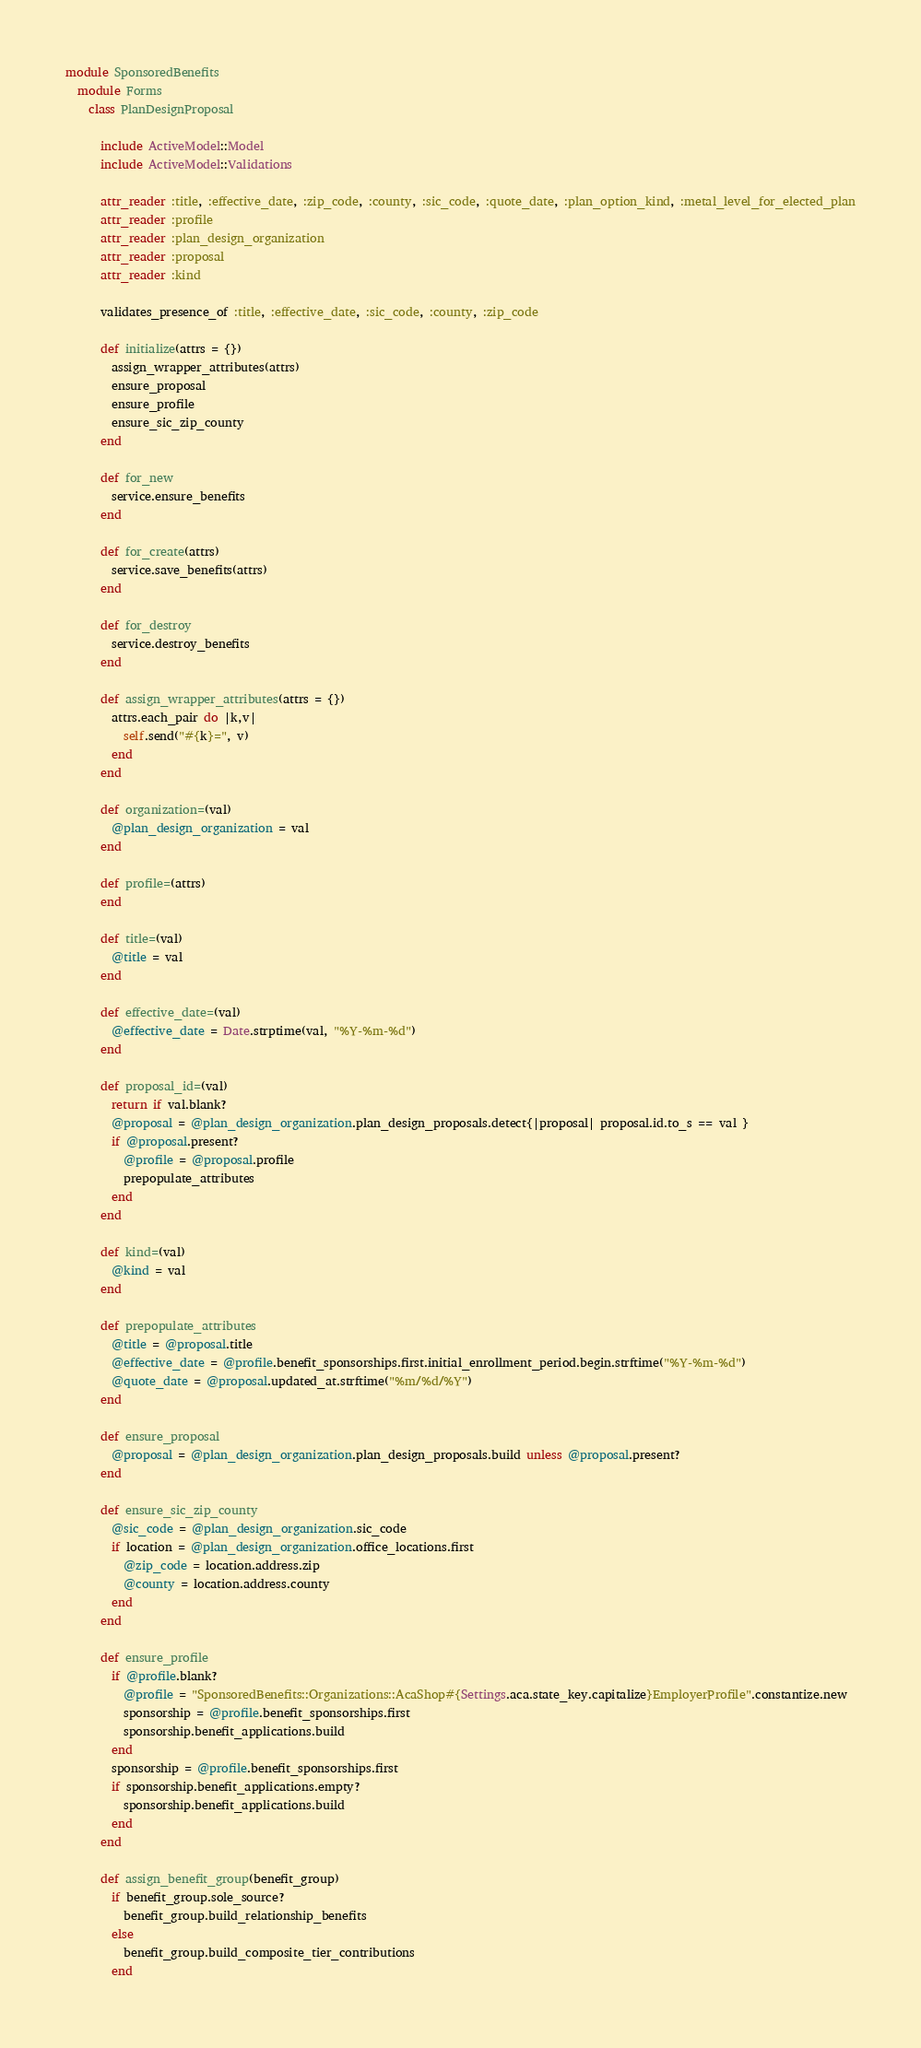Convert code to text. <code><loc_0><loc_0><loc_500><loc_500><_Ruby_>module SponsoredBenefits
  module Forms
    class PlanDesignProposal

      include ActiveModel::Model
      include ActiveModel::Validations

      attr_reader :title, :effective_date, :zip_code, :county, :sic_code, :quote_date, :plan_option_kind, :metal_level_for_elected_plan
      attr_reader :profile
      attr_reader :plan_design_organization
      attr_reader :proposal
      attr_reader :kind

      validates_presence_of :title, :effective_date, :sic_code, :county, :zip_code

      def initialize(attrs = {})
        assign_wrapper_attributes(attrs)
        ensure_proposal
        ensure_profile
        ensure_sic_zip_county
      end

      def for_new
        service.ensure_benefits
      end

      def for_create(attrs)
        service.save_benefits(attrs)
      end

      def for_destroy
        service.destroy_benefits
      end

      def assign_wrapper_attributes(attrs = {})
        attrs.each_pair do |k,v|
          self.send("#{k}=", v)
        end
      end

      def organization=(val)
        @plan_design_organization = val
      end

      def profile=(attrs)
      end

      def title=(val)
        @title = val
      end

      def effective_date=(val)
        @effective_date = Date.strptime(val, "%Y-%m-%d")
      end

      def proposal_id=(val)
        return if val.blank?
        @proposal = @plan_design_organization.plan_design_proposals.detect{|proposal| proposal.id.to_s == val }
        if @proposal.present?
          @profile = @proposal.profile
          prepopulate_attributes
        end
      end

      def kind=(val)
        @kind = val
      end

      def prepopulate_attributes
        @title = @proposal.title
        @effective_date = @profile.benefit_sponsorships.first.initial_enrollment_period.begin.strftime("%Y-%m-%d")
        @quote_date = @proposal.updated_at.strftime("%m/%d/%Y")
      end

      def ensure_proposal
        @proposal = @plan_design_organization.plan_design_proposals.build unless @proposal.present?
      end

      def ensure_sic_zip_county
        @sic_code = @plan_design_organization.sic_code
        if location = @plan_design_organization.office_locations.first
          @zip_code = location.address.zip
          @county = location.address.county
        end
      end

      def ensure_profile
        if @profile.blank?
          @profile = "SponsoredBenefits::Organizations::AcaShop#{Settings.aca.state_key.capitalize}EmployerProfile".constantize.new
          sponsorship = @profile.benefit_sponsorships.first
          sponsorship.benefit_applications.build
        end
        sponsorship = @profile.benefit_sponsorships.first
        if sponsorship.benefit_applications.empty?
          sponsorship.benefit_applications.build
        end
      end

      def assign_benefit_group(benefit_group)
        if benefit_group.sole_source?
          benefit_group.build_relationship_benefits
        else
          benefit_group.build_composite_tier_contributions
        end</code> 